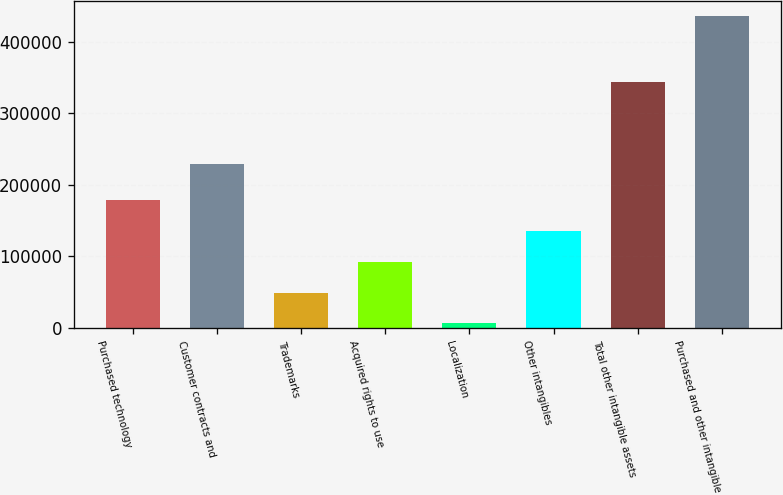<chart> <loc_0><loc_0><loc_500><loc_500><bar_chart><fcel>Purchased technology<fcel>Customer contracts and<fcel>Trademarks<fcel>Acquired rights to use<fcel>Localization<fcel>Other intangibles<fcel>Total other intangible assets<fcel>Purchased and other intangible<nl><fcel>178087<fcel>229364<fcel>49465.1<fcel>92339.2<fcel>6591<fcel>135213<fcel>343969<fcel>435332<nl></chart> 